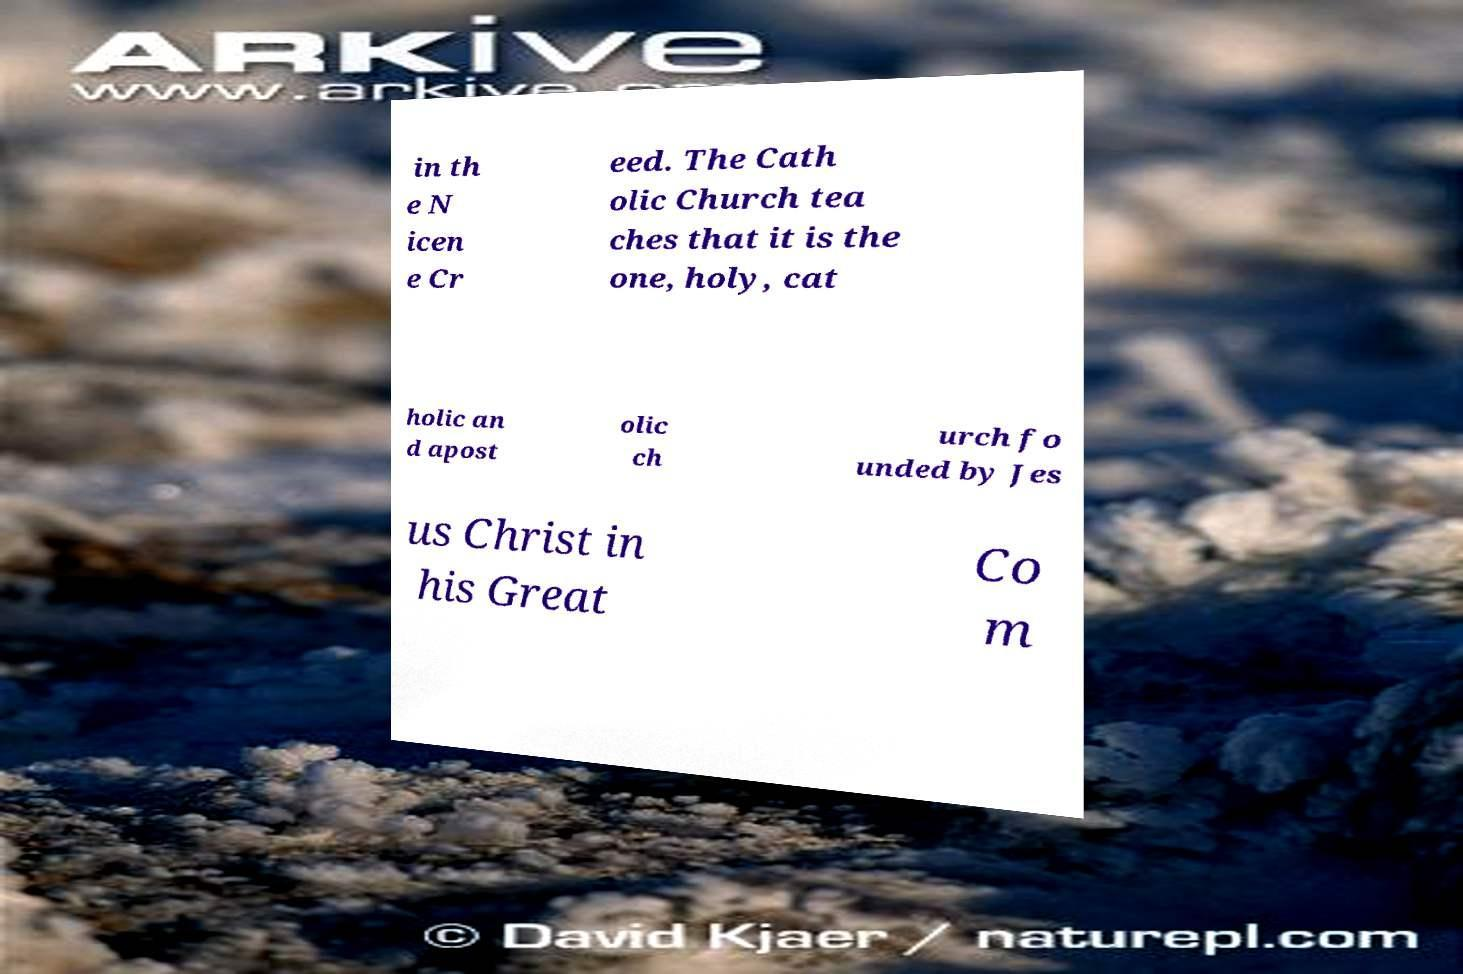There's text embedded in this image that I need extracted. Can you transcribe it verbatim? in th e N icen e Cr eed. The Cath olic Church tea ches that it is the one, holy, cat holic an d apost olic ch urch fo unded by Jes us Christ in his Great Co m 